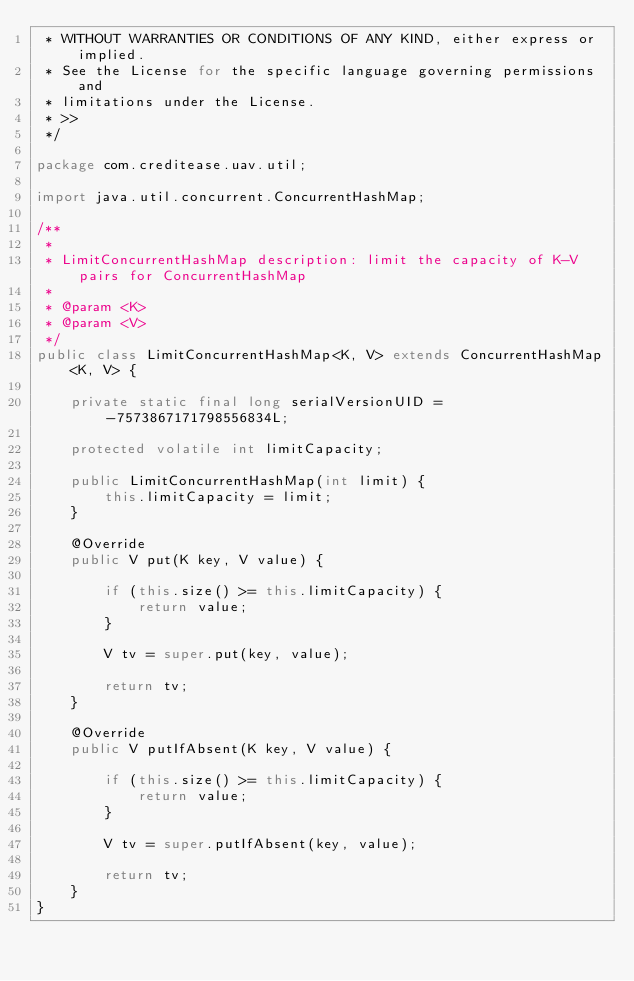<code> <loc_0><loc_0><loc_500><loc_500><_Java_> * WITHOUT WARRANTIES OR CONDITIONS OF ANY KIND, either express or implied.
 * See the License for the specific language governing permissions and
 * limitations under the License.
 * >>
 */

package com.creditease.uav.util;

import java.util.concurrent.ConcurrentHashMap;

/**
 * 
 * LimitConcurrentHashMap description: limit the capacity of K-V pairs for ConcurrentHashMap
 *
 * @param <K>
 * @param <V>
 */
public class LimitConcurrentHashMap<K, V> extends ConcurrentHashMap<K, V> {

    private static final long serialVersionUID = -7573867171798556834L;

    protected volatile int limitCapacity;

    public LimitConcurrentHashMap(int limit) {
        this.limitCapacity = limit;
    }

    @Override
    public V put(K key, V value) {

        if (this.size() >= this.limitCapacity) {
            return value;
        }

        V tv = super.put(key, value);

        return tv;
    }

    @Override
    public V putIfAbsent(K key, V value) {

        if (this.size() >= this.limitCapacity) {
            return value;
        }

        V tv = super.putIfAbsent(key, value);

        return tv;
    }
}
</code> 